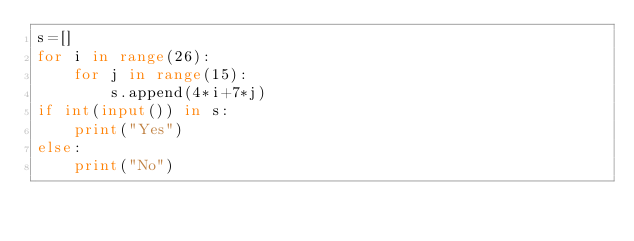<code> <loc_0><loc_0><loc_500><loc_500><_Python_>s=[]
for i in range(26):
    for j in range(15):
        s.append(4*i+7*j)
if int(input()) in s:
    print("Yes")
else:
    print("No")</code> 